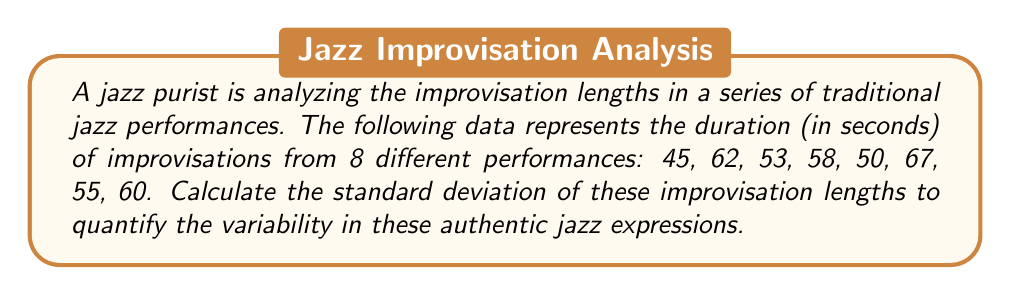Show me your answer to this math problem. To calculate the standard deviation, we'll follow these steps:

1. Calculate the mean ($\mu$) of the improvisation lengths:
   $$\mu = \frac{45 + 62 + 53 + 58 + 50 + 67 + 55 + 60}{8} = 56.25$$

2. Calculate the squared differences from the mean:
   $$(45 - 56.25)^2 = 126.5625$$
   $$(62 - 56.25)^2 = 33.0625$$
   $$(53 - 56.25)^2 = 10.5625$$
   $$(58 - 56.25)^2 = 3.0625$$
   $$(50 - 56.25)^2 = 39.0625$$
   $$(67 - 56.25)^2 = 115.5625$$
   $$(55 - 56.25)^2 = 1.5625$$
   $$(60 - 56.25)^2 = 14.0625$$

3. Calculate the variance ($\sigma^2$) by finding the average of these squared differences:
   $$\sigma^2 = \frac{126.5625 + 33.0625 + 10.5625 + 3.0625 + 39.0625 + 115.5625 + 1.5625 + 14.0625}{8} = 42.9375$$

4. Calculate the standard deviation ($\sigma$) by taking the square root of the variance:
   $$\sigma = \sqrt{42.9375} = 6.55$$

Therefore, the standard deviation of the improvisation lengths is approximately 6.55 seconds.
Answer: $6.55$ seconds 